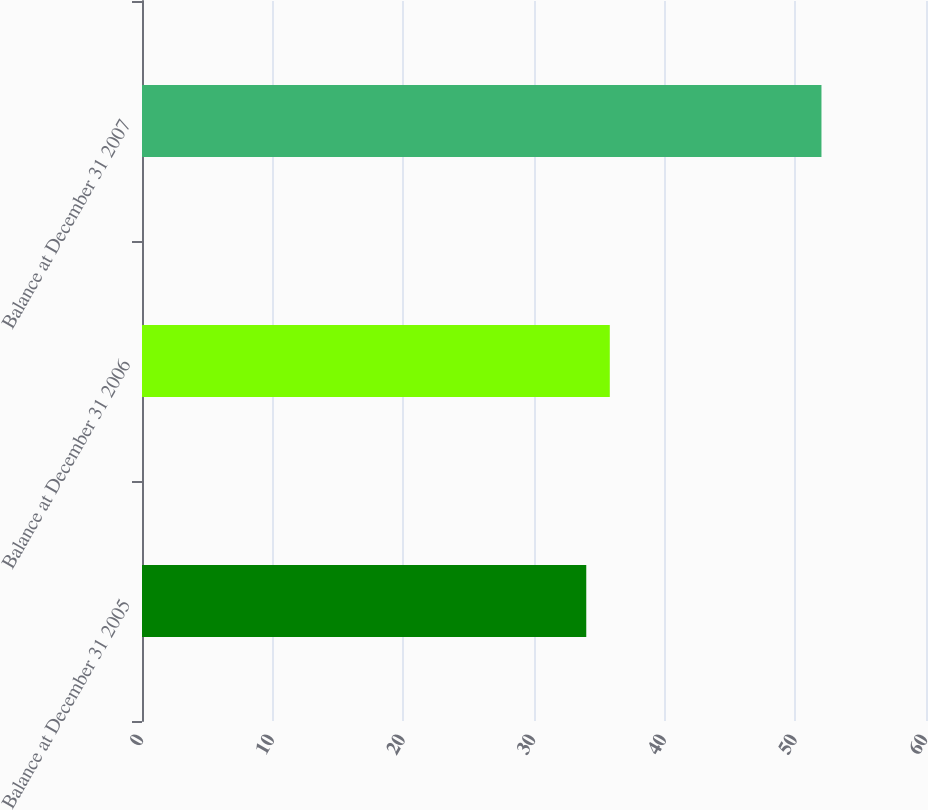Convert chart. <chart><loc_0><loc_0><loc_500><loc_500><bar_chart><fcel>Balance at December 31 2005<fcel>Balance at December 31 2006<fcel>Balance at December 31 2007<nl><fcel>34<fcel>35.8<fcel>52<nl></chart> 